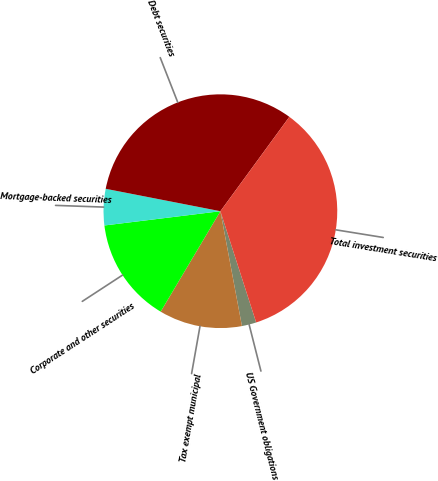<chart> <loc_0><loc_0><loc_500><loc_500><pie_chart><fcel>US Government obligations<fcel>Tax exempt municipal<fcel>Corporate and other securities<fcel>Mortgage-backed securities<fcel>Debt securities<fcel>Total investment securities<nl><fcel>2.0%<fcel>11.49%<fcel>14.51%<fcel>5.02%<fcel>31.97%<fcel>35.0%<nl></chart> 